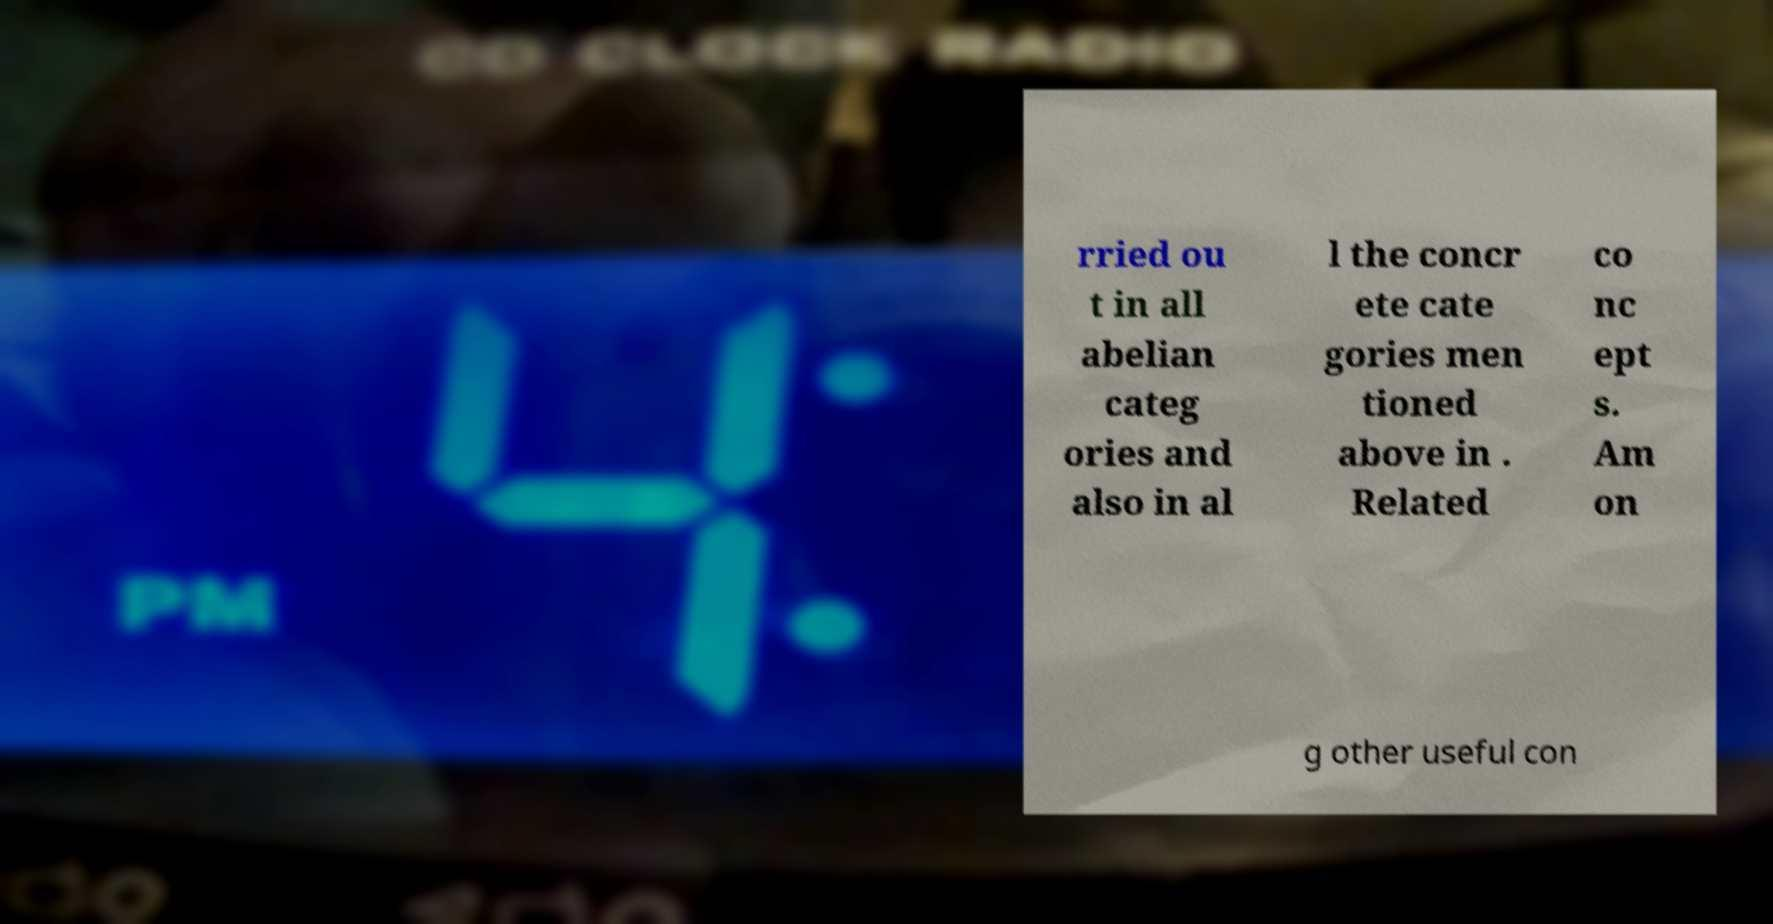Could you extract and type out the text from this image? rried ou t in all abelian categ ories and also in al l the concr ete cate gories men tioned above in . Related co nc ept s. Am on g other useful con 